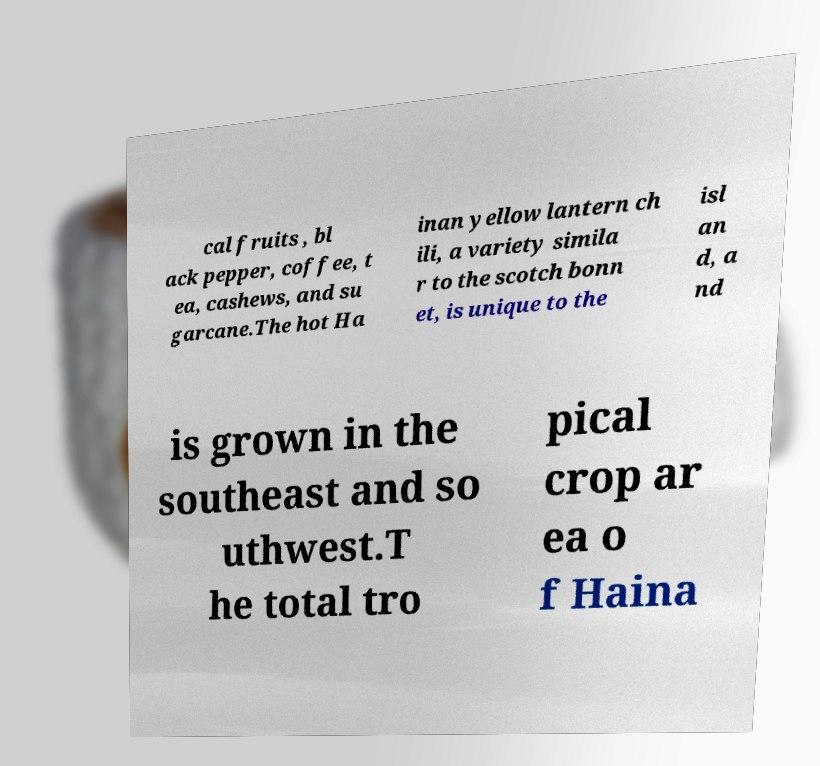There's text embedded in this image that I need extracted. Can you transcribe it verbatim? cal fruits , bl ack pepper, coffee, t ea, cashews, and su garcane.The hot Ha inan yellow lantern ch ili, a variety simila r to the scotch bonn et, is unique to the isl an d, a nd is grown in the southeast and so uthwest.T he total tro pical crop ar ea o f Haina 